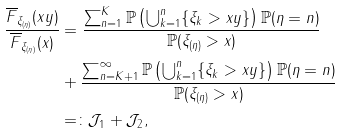Convert formula to latex. <formula><loc_0><loc_0><loc_500><loc_500>\frac { \overline { F } _ { \xi _ { ( \eta ) } } ( x y ) } { \overline { F } _ { \xi _ { ( \eta ) } } ( x ) } & = \frac { \sum _ { n = 1 } ^ { K } \mathbb { P } \left ( \bigcup _ { k = 1 } ^ { n } \{ \xi _ { k } > x y \} \right ) \mathbb { P } ( \eta = n ) } { \mathbb { P } ( \xi _ { ( \eta ) } > x ) } \\ & + \frac { \sum _ { n = K + 1 } ^ { \infty } \mathbb { P } \left ( \bigcup _ { k = 1 } ^ { n } \{ \xi _ { k } > x y \} \right ) \mathbb { P } ( \eta = n ) } { \mathbb { P } ( \xi _ { ( \eta ) } > x ) } \\ & = \colon \mathcal { J } _ { 1 } + \mathcal { J } _ { 2 } ,</formula> 